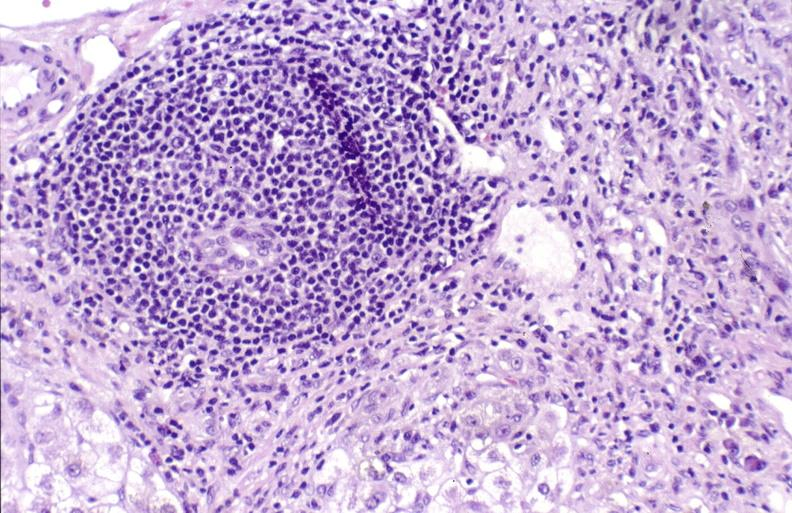does this image show primary biliary cirrhosis?
Answer the question using a single word or phrase. Yes 